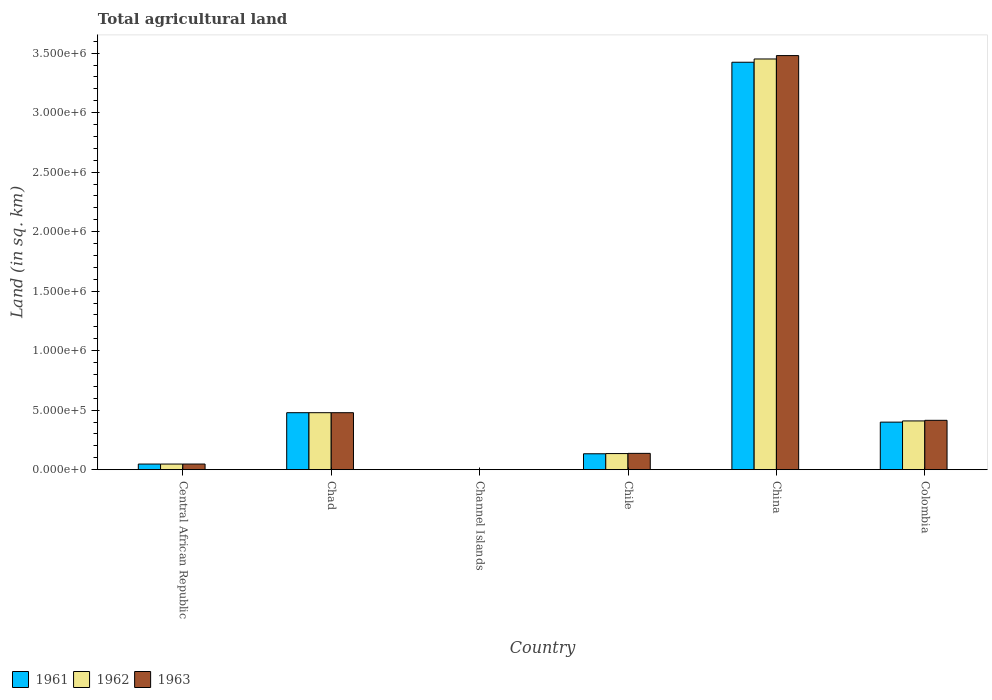How many different coloured bars are there?
Provide a short and direct response. 3. How many groups of bars are there?
Offer a terse response. 6. Are the number of bars per tick equal to the number of legend labels?
Your answer should be very brief. Yes. What is the total agricultural land in 1962 in Chile?
Offer a very short reply. 1.36e+05. Across all countries, what is the maximum total agricultural land in 1961?
Your response must be concise. 3.42e+06. Across all countries, what is the minimum total agricultural land in 1961?
Offer a very short reply. 90. In which country was the total agricultural land in 1961 minimum?
Your answer should be compact. Channel Islands. What is the total total agricultural land in 1961 in the graph?
Ensure brevity in your answer.  4.48e+06. What is the difference between the total agricultural land in 1961 in Central African Republic and that in Channel Islands?
Make the answer very short. 4.73e+04. What is the difference between the total agricultural land in 1962 in Colombia and the total agricultural land in 1961 in China?
Your response must be concise. -3.01e+06. What is the average total agricultural land in 1963 per country?
Keep it short and to the point. 7.60e+05. What is the difference between the total agricultural land of/in 1961 and total agricultural land of/in 1963 in Channel Islands?
Give a very brief answer. 0. What is the ratio of the total agricultural land in 1963 in Channel Islands to that in Colombia?
Give a very brief answer. 0. Is the total agricultural land in 1963 in Channel Islands less than that in China?
Offer a terse response. Yes. What is the difference between the highest and the second highest total agricultural land in 1962?
Offer a very short reply. 2.97e+06. What is the difference between the highest and the lowest total agricultural land in 1963?
Offer a very short reply. 3.48e+06. Is the sum of the total agricultural land in 1963 in Central African Republic and Channel Islands greater than the maximum total agricultural land in 1962 across all countries?
Provide a succinct answer. No. What does the 3rd bar from the left in Chad represents?
Give a very brief answer. 1963. What does the 2nd bar from the right in China represents?
Offer a very short reply. 1962. Is it the case that in every country, the sum of the total agricultural land in 1962 and total agricultural land in 1961 is greater than the total agricultural land in 1963?
Make the answer very short. Yes. How many bars are there?
Provide a short and direct response. 18. How many countries are there in the graph?
Your answer should be very brief. 6. What is the difference between two consecutive major ticks on the Y-axis?
Your answer should be very brief. 5.00e+05. Does the graph contain any zero values?
Ensure brevity in your answer.  No. How many legend labels are there?
Your answer should be compact. 3. How are the legend labels stacked?
Your response must be concise. Horizontal. What is the title of the graph?
Ensure brevity in your answer.  Total agricultural land. Does "1991" appear as one of the legend labels in the graph?
Make the answer very short. No. What is the label or title of the X-axis?
Offer a very short reply. Country. What is the label or title of the Y-axis?
Provide a succinct answer. Land (in sq. km). What is the Land (in sq. km) of 1961 in Central African Republic?
Offer a terse response. 4.74e+04. What is the Land (in sq. km) of 1962 in Central African Republic?
Your answer should be compact. 4.75e+04. What is the Land (in sq. km) in 1963 in Central African Republic?
Your response must be concise. 4.76e+04. What is the Land (in sq. km) of 1961 in Chad?
Ensure brevity in your answer.  4.79e+05. What is the Land (in sq. km) in 1962 in Chad?
Make the answer very short. 4.79e+05. What is the Land (in sq. km) of 1963 in Chad?
Your response must be concise. 4.79e+05. What is the Land (in sq. km) in 1961 in Channel Islands?
Your answer should be compact. 90. What is the Land (in sq. km) of 1963 in Channel Islands?
Offer a very short reply. 90. What is the Land (in sq. km) in 1961 in Chile?
Ensure brevity in your answer.  1.34e+05. What is the Land (in sq. km) in 1962 in Chile?
Offer a very short reply. 1.36e+05. What is the Land (in sq. km) of 1963 in Chile?
Make the answer very short. 1.37e+05. What is the Land (in sq. km) in 1961 in China?
Provide a succinct answer. 3.42e+06. What is the Land (in sq. km) in 1962 in China?
Ensure brevity in your answer.  3.45e+06. What is the Land (in sq. km) of 1963 in China?
Provide a succinct answer. 3.48e+06. What is the Land (in sq. km) in 1961 in Colombia?
Give a very brief answer. 4.00e+05. What is the Land (in sq. km) in 1962 in Colombia?
Your answer should be very brief. 4.10e+05. What is the Land (in sq. km) in 1963 in Colombia?
Your response must be concise. 4.15e+05. Across all countries, what is the maximum Land (in sq. km) of 1961?
Ensure brevity in your answer.  3.42e+06. Across all countries, what is the maximum Land (in sq. km) of 1962?
Offer a very short reply. 3.45e+06. Across all countries, what is the maximum Land (in sq. km) of 1963?
Give a very brief answer. 3.48e+06. Across all countries, what is the minimum Land (in sq. km) in 1962?
Give a very brief answer. 90. What is the total Land (in sq. km) in 1961 in the graph?
Your answer should be very brief. 4.48e+06. What is the total Land (in sq. km) of 1962 in the graph?
Ensure brevity in your answer.  4.52e+06. What is the total Land (in sq. km) in 1963 in the graph?
Your response must be concise. 4.56e+06. What is the difference between the Land (in sq. km) of 1961 in Central African Republic and that in Chad?
Provide a short and direct response. -4.32e+05. What is the difference between the Land (in sq. km) of 1962 in Central African Republic and that in Chad?
Your answer should be very brief. -4.32e+05. What is the difference between the Land (in sq. km) of 1963 in Central African Republic and that in Chad?
Offer a terse response. -4.31e+05. What is the difference between the Land (in sq. km) of 1961 in Central African Republic and that in Channel Islands?
Keep it short and to the point. 4.73e+04. What is the difference between the Land (in sq. km) of 1962 in Central African Republic and that in Channel Islands?
Provide a succinct answer. 4.74e+04. What is the difference between the Land (in sq. km) of 1963 in Central African Republic and that in Channel Islands?
Make the answer very short. 4.75e+04. What is the difference between the Land (in sq. km) of 1961 in Central African Republic and that in Chile?
Ensure brevity in your answer.  -8.65e+04. What is the difference between the Land (in sq. km) in 1962 in Central African Republic and that in Chile?
Provide a succinct answer. -8.81e+04. What is the difference between the Land (in sq. km) in 1963 in Central African Republic and that in Chile?
Your response must be concise. -8.97e+04. What is the difference between the Land (in sq. km) in 1961 in Central African Republic and that in China?
Provide a succinct answer. -3.38e+06. What is the difference between the Land (in sq. km) in 1962 in Central African Republic and that in China?
Make the answer very short. -3.40e+06. What is the difference between the Land (in sq. km) of 1963 in Central African Republic and that in China?
Provide a succinct answer. -3.43e+06. What is the difference between the Land (in sq. km) of 1961 in Central African Republic and that in Colombia?
Your response must be concise. -3.52e+05. What is the difference between the Land (in sq. km) of 1962 in Central African Republic and that in Colombia?
Offer a very short reply. -3.62e+05. What is the difference between the Land (in sq. km) in 1963 in Central African Republic and that in Colombia?
Keep it short and to the point. -3.67e+05. What is the difference between the Land (in sq. km) of 1961 in Chad and that in Channel Islands?
Keep it short and to the point. 4.79e+05. What is the difference between the Land (in sq. km) of 1962 in Chad and that in Channel Islands?
Give a very brief answer. 4.79e+05. What is the difference between the Land (in sq. km) of 1963 in Chad and that in Channel Islands?
Your response must be concise. 4.79e+05. What is the difference between the Land (in sq. km) in 1961 in Chad and that in Chile?
Provide a short and direct response. 3.45e+05. What is the difference between the Land (in sq. km) of 1962 in Chad and that in Chile?
Your answer should be compact. 3.43e+05. What is the difference between the Land (in sq. km) of 1963 in Chad and that in Chile?
Ensure brevity in your answer.  3.42e+05. What is the difference between the Land (in sq. km) in 1961 in Chad and that in China?
Ensure brevity in your answer.  -2.94e+06. What is the difference between the Land (in sq. km) in 1962 in Chad and that in China?
Your response must be concise. -2.97e+06. What is the difference between the Land (in sq. km) of 1963 in Chad and that in China?
Provide a short and direct response. -3.00e+06. What is the difference between the Land (in sq. km) in 1961 in Chad and that in Colombia?
Ensure brevity in your answer.  7.93e+04. What is the difference between the Land (in sq. km) in 1962 in Chad and that in Colombia?
Offer a very short reply. 6.93e+04. What is the difference between the Land (in sq. km) of 1963 in Chad and that in Colombia?
Your response must be concise. 6.41e+04. What is the difference between the Land (in sq. km) of 1961 in Channel Islands and that in Chile?
Ensure brevity in your answer.  -1.34e+05. What is the difference between the Land (in sq. km) in 1962 in Channel Islands and that in Chile?
Your answer should be compact. -1.35e+05. What is the difference between the Land (in sq. km) of 1963 in Channel Islands and that in Chile?
Offer a terse response. -1.37e+05. What is the difference between the Land (in sq. km) in 1961 in Channel Islands and that in China?
Provide a succinct answer. -3.42e+06. What is the difference between the Land (in sq. km) in 1962 in Channel Islands and that in China?
Your response must be concise. -3.45e+06. What is the difference between the Land (in sq. km) in 1963 in Channel Islands and that in China?
Offer a very short reply. -3.48e+06. What is the difference between the Land (in sq. km) in 1961 in Channel Islands and that in Colombia?
Offer a terse response. -4.00e+05. What is the difference between the Land (in sq. km) of 1962 in Channel Islands and that in Colombia?
Offer a terse response. -4.10e+05. What is the difference between the Land (in sq. km) in 1963 in Channel Islands and that in Colombia?
Give a very brief answer. -4.15e+05. What is the difference between the Land (in sq. km) of 1961 in Chile and that in China?
Make the answer very short. -3.29e+06. What is the difference between the Land (in sq. km) of 1962 in Chile and that in China?
Your answer should be compact. -3.32e+06. What is the difference between the Land (in sq. km) of 1963 in Chile and that in China?
Offer a very short reply. -3.34e+06. What is the difference between the Land (in sq. km) of 1961 in Chile and that in Colombia?
Your answer should be very brief. -2.66e+05. What is the difference between the Land (in sq. km) in 1962 in Chile and that in Colombia?
Your response must be concise. -2.74e+05. What is the difference between the Land (in sq. km) in 1963 in Chile and that in Colombia?
Keep it short and to the point. -2.78e+05. What is the difference between the Land (in sq. km) of 1961 in China and that in Colombia?
Ensure brevity in your answer.  3.02e+06. What is the difference between the Land (in sq. km) of 1962 in China and that in Colombia?
Give a very brief answer. 3.04e+06. What is the difference between the Land (in sq. km) of 1963 in China and that in Colombia?
Ensure brevity in your answer.  3.06e+06. What is the difference between the Land (in sq. km) in 1961 in Central African Republic and the Land (in sq. km) in 1962 in Chad?
Give a very brief answer. -4.32e+05. What is the difference between the Land (in sq. km) of 1961 in Central African Republic and the Land (in sq. km) of 1963 in Chad?
Give a very brief answer. -4.32e+05. What is the difference between the Land (in sq. km) in 1962 in Central African Republic and the Land (in sq. km) in 1963 in Chad?
Ensure brevity in your answer.  -4.32e+05. What is the difference between the Land (in sq. km) of 1961 in Central African Republic and the Land (in sq. km) of 1962 in Channel Islands?
Your response must be concise. 4.73e+04. What is the difference between the Land (in sq. km) in 1961 in Central African Republic and the Land (in sq. km) in 1963 in Channel Islands?
Provide a succinct answer. 4.73e+04. What is the difference between the Land (in sq. km) in 1962 in Central African Republic and the Land (in sq. km) in 1963 in Channel Islands?
Offer a very short reply. 4.74e+04. What is the difference between the Land (in sq. km) in 1961 in Central African Republic and the Land (in sq. km) in 1962 in Chile?
Offer a very short reply. -8.82e+04. What is the difference between the Land (in sq. km) of 1961 in Central African Republic and the Land (in sq. km) of 1963 in Chile?
Your response must be concise. -8.99e+04. What is the difference between the Land (in sq. km) of 1962 in Central African Republic and the Land (in sq. km) of 1963 in Chile?
Your answer should be compact. -8.98e+04. What is the difference between the Land (in sq. km) of 1961 in Central African Republic and the Land (in sq. km) of 1962 in China?
Keep it short and to the point. -3.40e+06. What is the difference between the Land (in sq. km) of 1961 in Central African Republic and the Land (in sq. km) of 1963 in China?
Your answer should be compact. -3.43e+06. What is the difference between the Land (in sq. km) in 1962 in Central African Republic and the Land (in sq. km) in 1963 in China?
Make the answer very short. -3.43e+06. What is the difference between the Land (in sq. km) in 1961 in Central African Republic and the Land (in sq. km) in 1962 in Colombia?
Offer a very short reply. -3.62e+05. What is the difference between the Land (in sq. km) in 1961 in Central African Republic and the Land (in sq. km) in 1963 in Colombia?
Your answer should be very brief. -3.68e+05. What is the difference between the Land (in sq. km) of 1962 in Central African Republic and the Land (in sq. km) of 1963 in Colombia?
Your answer should be compact. -3.67e+05. What is the difference between the Land (in sq. km) in 1961 in Chad and the Land (in sq. km) in 1962 in Channel Islands?
Ensure brevity in your answer.  4.79e+05. What is the difference between the Land (in sq. km) of 1961 in Chad and the Land (in sq. km) of 1963 in Channel Islands?
Your answer should be very brief. 4.79e+05. What is the difference between the Land (in sq. km) in 1962 in Chad and the Land (in sq. km) in 1963 in Channel Islands?
Your response must be concise. 4.79e+05. What is the difference between the Land (in sq. km) of 1961 in Chad and the Land (in sq. km) of 1962 in Chile?
Provide a short and direct response. 3.43e+05. What is the difference between the Land (in sq. km) of 1961 in Chad and the Land (in sq. km) of 1963 in Chile?
Give a very brief answer. 3.42e+05. What is the difference between the Land (in sq. km) in 1962 in Chad and the Land (in sq. km) in 1963 in Chile?
Your answer should be compact. 3.42e+05. What is the difference between the Land (in sq. km) of 1961 in Chad and the Land (in sq. km) of 1962 in China?
Your answer should be compact. -2.97e+06. What is the difference between the Land (in sq. km) of 1961 in Chad and the Land (in sq. km) of 1963 in China?
Offer a terse response. -3.00e+06. What is the difference between the Land (in sq. km) in 1962 in Chad and the Land (in sq. km) in 1963 in China?
Keep it short and to the point. -3.00e+06. What is the difference between the Land (in sq. km) in 1961 in Chad and the Land (in sq. km) in 1962 in Colombia?
Provide a succinct answer. 6.93e+04. What is the difference between the Land (in sq. km) in 1961 in Chad and the Land (in sq. km) in 1963 in Colombia?
Offer a terse response. 6.41e+04. What is the difference between the Land (in sq. km) of 1962 in Chad and the Land (in sq. km) of 1963 in Colombia?
Give a very brief answer. 6.41e+04. What is the difference between the Land (in sq. km) in 1961 in Channel Islands and the Land (in sq. km) in 1962 in Chile?
Keep it short and to the point. -1.35e+05. What is the difference between the Land (in sq. km) in 1961 in Channel Islands and the Land (in sq. km) in 1963 in Chile?
Offer a terse response. -1.37e+05. What is the difference between the Land (in sq. km) of 1962 in Channel Islands and the Land (in sq. km) of 1963 in Chile?
Your answer should be compact. -1.37e+05. What is the difference between the Land (in sq. km) of 1961 in Channel Islands and the Land (in sq. km) of 1962 in China?
Give a very brief answer. -3.45e+06. What is the difference between the Land (in sq. km) in 1961 in Channel Islands and the Land (in sq. km) in 1963 in China?
Keep it short and to the point. -3.48e+06. What is the difference between the Land (in sq. km) in 1962 in Channel Islands and the Land (in sq. km) in 1963 in China?
Offer a very short reply. -3.48e+06. What is the difference between the Land (in sq. km) of 1961 in Channel Islands and the Land (in sq. km) of 1962 in Colombia?
Make the answer very short. -4.10e+05. What is the difference between the Land (in sq. km) in 1961 in Channel Islands and the Land (in sq. km) in 1963 in Colombia?
Make the answer very short. -4.15e+05. What is the difference between the Land (in sq. km) of 1962 in Channel Islands and the Land (in sq. km) of 1963 in Colombia?
Offer a very short reply. -4.15e+05. What is the difference between the Land (in sq. km) in 1961 in Chile and the Land (in sq. km) in 1962 in China?
Keep it short and to the point. -3.32e+06. What is the difference between the Land (in sq. km) in 1961 in Chile and the Land (in sq. km) in 1963 in China?
Provide a short and direct response. -3.35e+06. What is the difference between the Land (in sq. km) of 1962 in Chile and the Land (in sq. km) of 1963 in China?
Ensure brevity in your answer.  -3.34e+06. What is the difference between the Land (in sq. km) in 1961 in Chile and the Land (in sq. km) in 1962 in Colombia?
Provide a short and direct response. -2.76e+05. What is the difference between the Land (in sq. km) in 1961 in Chile and the Land (in sq. km) in 1963 in Colombia?
Give a very brief answer. -2.81e+05. What is the difference between the Land (in sq. km) of 1962 in Chile and the Land (in sq. km) of 1963 in Colombia?
Your answer should be compact. -2.79e+05. What is the difference between the Land (in sq. km) of 1961 in China and the Land (in sq. km) of 1962 in Colombia?
Offer a terse response. 3.01e+06. What is the difference between the Land (in sq. km) of 1961 in China and the Land (in sq. km) of 1963 in Colombia?
Give a very brief answer. 3.01e+06. What is the difference between the Land (in sq. km) of 1962 in China and the Land (in sq. km) of 1963 in Colombia?
Keep it short and to the point. 3.04e+06. What is the average Land (in sq. km) in 1961 per country?
Your answer should be compact. 7.47e+05. What is the average Land (in sq. km) in 1962 per country?
Your answer should be compact. 7.54e+05. What is the average Land (in sq. km) in 1963 per country?
Your response must be concise. 7.60e+05. What is the difference between the Land (in sq. km) in 1961 and Land (in sq. km) in 1962 in Central African Republic?
Keep it short and to the point. -100. What is the difference between the Land (in sq. km) of 1961 and Land (in sq. km) of 1963 in Central African Republic?
Keep it short and to the point. -180. What is the difference between the Land (in sq. km) in 1962 and Land (in sq. km) in 1963 in Central African Republic?
Offer a terse response. -80. What is the difference between the Land (in sq. km) in 1962 and Land (in sq. km) in 1963 in Channel Islands?
Ensure brevity in your answer.  0. What is the difference between the Land (in sq. km) of 1961 and Land (in sq. km) of 1962 in Chile?
Your answer should be compact. -1700. What is the difference between the Land (in sq. km) in 1961 and Land (in sq. km) in 1963 in Chile?
Keep it short and to the point. -3400. What is the difference between the Land (in sq. km) of 1962 and Land (in sq. km) of 1963 in Chile?
Keep it short and to the point. -1700. What is the difference between the Land (in sq. km) in 1961 and Land (in sq. km) in 1962 in China?
Keep it short and to the point. -2.75e+04. What is the difference between the Land (in sq. km) of 1961 and Land (in sq. km) of 1963 in China?
Offer a very short reply. -5.60e+04. What is the difference between the Land (in sq. km) of 1962 and Land (in sq. km) of 1963 in China?
Provide a succinct answer. -2.85e+04. What is the difference between the Land (in sq. km) of 1961 and Land (in sq. km) of 1962 in Colombia?
Keep it short and to the point. -1.00e+04. What is the difference between the Land (in sq. km) in 1961 and Land (in sq. km) in 1963 in Colombia?
Your answer should be compact. -1.52e+04. What is the difference between the Land (in sq. km) in 1962 and Land (in sq. km) in 1963 in Colombia?
Your response must be concise. -5210. What is the ratio of the Land (in sq. km) of 1961 in Central African Republic to that in Chad?
Your answer should be very brief. 0.1. What is the ratio of the Land (in sq. km) in 1962 in Central African Republic to that in Chad?
Provide a short and direct response. 0.1. What is the ratio of the Land (in sq. km) of 1963 in Central African Republic to that in Chad?
Give a very brief answer. 0.1. What is the ratio of the Land (in sq. km) of 1961 in Central African Republic to that in Channel Islands?
Give a very brief answer. 526.44. What is the ratio of the Land (in sq. km) of 1962 in Central African Republic to that in Channel Islands?
Provide a short and direct response. 527.56. What is the ratio of the Land (in sq. km) of 1963 in Central African Republic to that in Channel Islands?
Ensure brevity in your answer.  528.44. What is the ratio of the Land (in sq. km) in 1961 in Central African Republic to that in Chile?
Make the answer very short. 0.35. What is the ratio of the Land (in sq. km) of 1962 in Central African Republic to that in Chile?
Make the answer very short. 0.35. What is the ratio of the Land (in sq. km) of 1963 in Central African Republic to that in Chile?
Offer a very short reply. 0.35. What is the ratio of the Land (in sq. km) of 1961 in Central African Republic to that in China?
Your answer should be very brief. 0.01. What is the ratio of the Land (in sq. km) in 1962 in Central African Republic to that in China?
Ensure brevity in your answer.  0.01. What is the ratio of the Land (in sq. km) of 1963 in Central African Republic to that in China?
Provide a succinct answer. 0.01. What is the ratio of the Land (in sq. km) in 1961 in Central African Republic to that in Colombia?
Provide a succinct answer. 0.12. What is the ratio of the Land (in sq. km) in 1962 in Central African Republic to that in Colombia?
Give a very brief answer. 0.12. What is the ratio of the Land (in sq. km) of 1963 in Central African Republic to that in Colombia?
Give a very brief answer. 0.11. What is the ratio of the Land (in sq. km) of 1961 in Chad to that in Channel Islands?
Keep it short and to the point. 5322.22. What is the ratio of the Land (in sq. km) of 1962 in Chad to that in Channel Islands?
Your response must be concise. 5322.22. What is the ratio of the Land (in sq. km) of 1963 in Chad to that in Channel Islands?
Provide a short and direct response. 5322.22. What is the ratio of the Land (in sq. km) in 1961 in Chad to that in Chile?
Provide a short and direct response. 3.58. What is the ratio of the Land (in sq. km) in 1962 in Chad to that in Chile?
Ensure brevity in your answer.  3.53. What is the ratio of the Land (in sq. km) of 1963 in Chad to that in Chile?
Ensure brevity in your answer.  3.49. What is the ratio of the Land (in sq. km) of 1961 in Chad to that in China?
Give a very brief answer. 0.14. What is the ratio of the Land (in sq. km) of 1962 in Chad to that in China?
Give a very brief answer. 0.14. What is the ratio of the Land (in sq. km) of 1963 in Chad to that in China?
Offer a terse response. 0.14. What is the ratio of the Land (in sq. km) in 1961 in Chad to that in Colombia?
Give a very brief answer. 1.2. What is the ratio of the Land (in sq. km) of 1962 in Chad to that in Colombia?
Make the answer very short. 1.17. What is the ratio of the Land (in sq. km) of 1963 in Chad to that in Colombia?
Your answer should be very brief. 1.15. What is the ratio of the Land (in sq. km) of 1961 in Channel Islands to that in Chile?
Provide a short and direct response. 0. What is the ratio of the Land (in sq. km) of 1962 in Channel Islands to that in Chile?
Offer a very short reply. 0. What is the ratio of the Land (in sq. km) of 1963 in Channel Islands to that in Chile?
Provide a succinct answer. 0. What is the ratio of the Land (in sq. km) of 1961 in Channel Islands to that in China?
Your response must be concise. 0. What is the ratio of the Land (in sq. km) in 1961 in Channel Islands to that in Colombia?
Offer a terse response. 0. What is the ratio of the Land (in sq. km) of 1961 in Chile to that in China?
Your answer should be very brief. 0.04. What is the ratio of the Land (in sq. km) in 1962 in Chile to that in China?
Keep it short and to the point. 0.04. What is the ratio of the Land (in sq. km) in 1963 in Chile to that in China?
Provide a succinct answer. 0.04. What is the ratio of the Land (in sq. km) of 1961 in Chile to that in Colombia?
Offer a terse response. 0.33. What is the ratio of the Land (in sq. km) in 1962 in Chile to that in Colombia?
Your answer should be very brief. 0.33. What is the ratio of the Land (in sq. km) of 1963 in Chile to that in Colombia?
Your answer should be very brief. 0.33. What is the ratio of the Land (in sq. km) of 1961 in China to that in Colombia?
Offer a very short reply. 8.57. What is the ratio of the Land (in sq. km) of 1962 in China to that in Colombia?
Your response must be concise. 8.42. What is the ratio of the Land (in sq. km) of 1963 in China to that in Colombia?
Your answer should be compact. 8.39. What is the difference between the highest and the second highest Land (in sq. km) in 1961?
Ensure brevity in your answer.  2.94e+06. What is the difference between the highest and the second highest Land (in sq. km) in 1962?
Offer a terse response. 2.97e+06. What is the difference between the highest and the second highest Land (in sq. km) of 1963?
Your response must be concise. 3.00e+06. What is the difference between the highest and the lowest Land (in sq. km) in 1961?
Your response must be concise. 3.42e+06. What is the difference between the highest and the lowest Land (in sq. km) in 1962?
Keep it short and to the point. 3.45e+06. What is the difference between the highest and the lowest Land (in sq. km) of 1963?
Make the answer very short. 3.48e+06. 